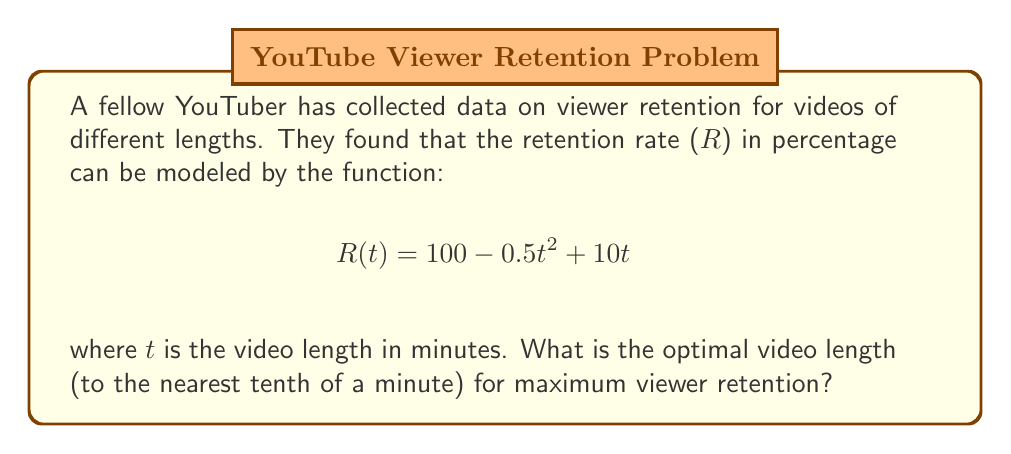Show me your answer to this math problem. To find the optimal video length for maximum viewer retention, we need to find the maximum point of the function R(t). This can be done by following these steps:

1. Find the derivative of R(t):
   $$R'(t) = -t + 10$$

2. Set the derivative equal to zero and solve for t:
   $$R'(t) = 0$$
   $$-t + 10 = 0$$
   $$t = 10$$

3. Verify that this critical point is a maximum by checking the second derivative:
   $$R''(t) = -1$$
   Since R''(t) is negative, the critical point is indeed a maximum.

4. Round the result to the nearest tenth:
   t ≈ 10.0 minutes

Therefore, the optimal video length for maximum viewer retention is 10.0 minutes.
Answer: 10.0 minutes 